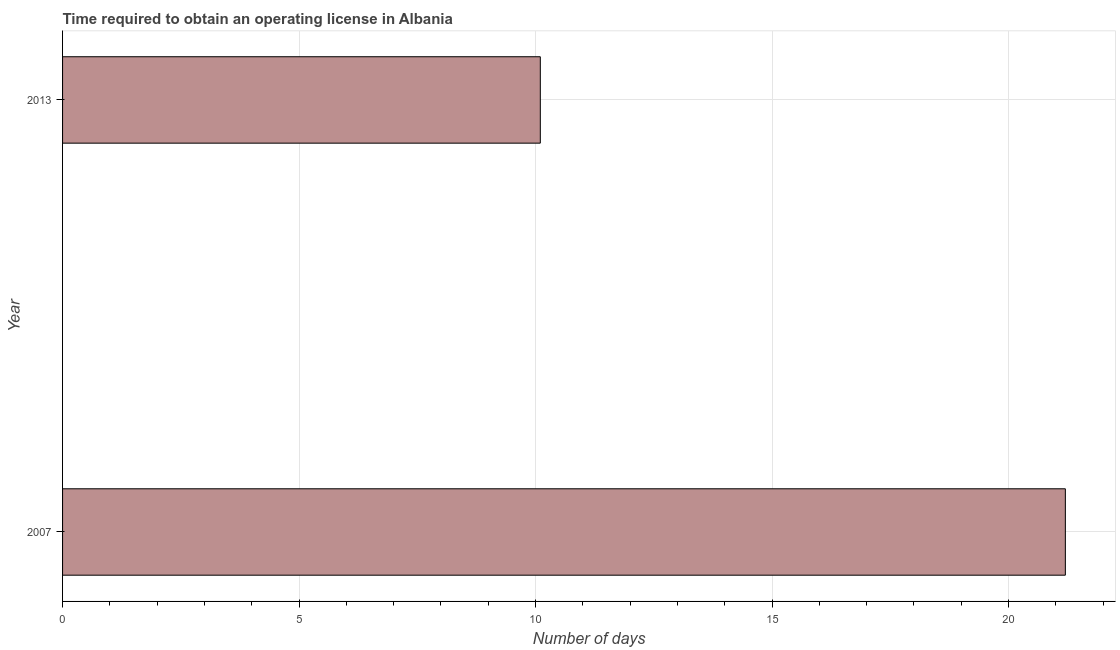Does the graph contain grids?
Provide a short and direct response. Yes. What is the title of the graph?
Offer a very short reply. Time required to obtain an operating license in Albania. What is the label or title of the X-axis?
Your answer should be compact. Number of days. What is the number of days to obtain operating license in 2007?
Offer a terse response. 21.2. Across all years, what is the maximum number of days to obtain operating license?
Keep it short and to the point. 21.2. In which year was the number of days to obtain operating license minimum?
Ensure brevity in your answer.  2013. What is the sum of the number of days to obtain operating license?
Your answer should be compact. 31.3. What is the average number of days to obtain operating license per year?
Your answer should be very brief. 15.65. What is the median number of days to obtain operating license?
Your response must be concise. 15.65. What is the ratio of the number of days to obtain operating license in 2007 to that in 2013?
Make the answer very short. 2.1. Is the number of days to obtain operating license in 2007 less than that in 2013?
Ensure brevity in your answer.  No. In how many years, is the number of days to obtain operating license greater than the average number of days to obtain operating license taken over all years?
Provide a short and direct response. 1. How many bars are there?
Make the answer very short. 2. Are all the bars in the graph horizontal?
Make the answer very short. Yes. What is the difference between two consecutive major ticks on the X-axis?
Your answer should be compact. 5. What is the Number of days in 2007?
Give a very brief answer. 21.2. What is the difference between the Number of days in 2007 and 2013?
Provide a short and direct response. 11.1. What is the ratio of the Number of days in 2007 to that in 2013?
Your answer should be very brief. 2.1. 